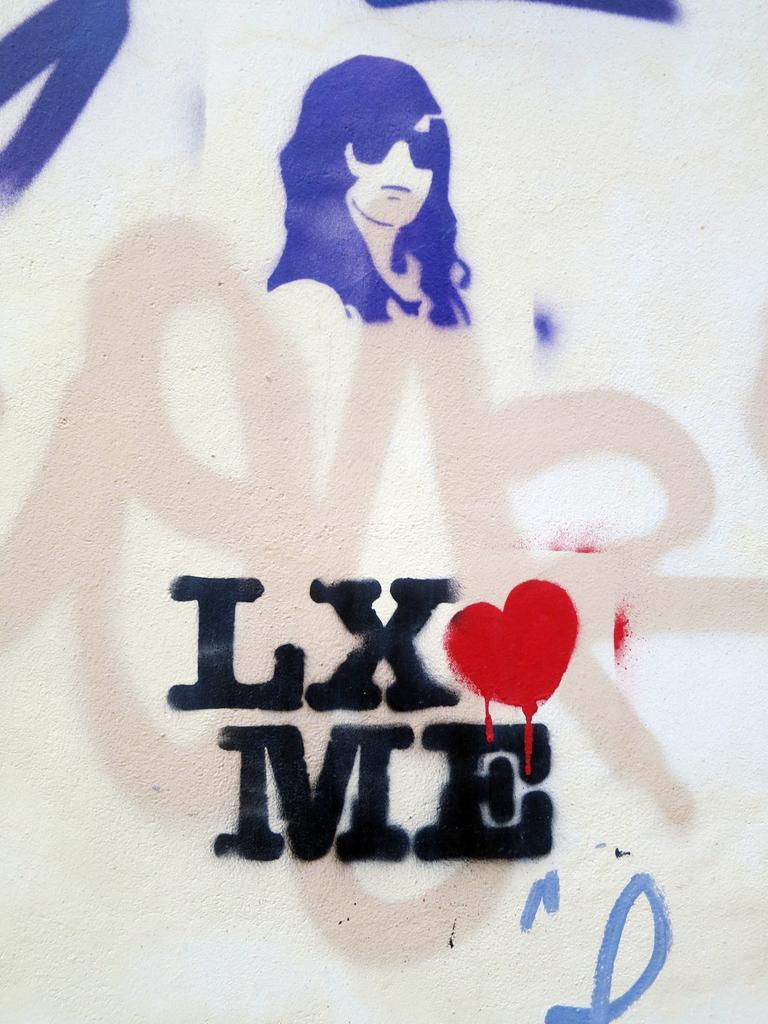Please provide a concise description of this image. Here in this picture we can see some sort of painting drawn on the wall over there. 